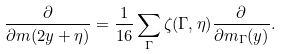Convert formula to latex. <formula><loc_0><loc_0><loc_500><loc_500>\frac { \partial } { \partial m ( 2 y + \eta ) } = \frac { 1 } { 1 6 } \sum _ { \Gamma } \zeta ( \Gamma , \eta ) \frac { \partial } { \partial m _ { \Gamma } ( y ) } .</formula> 